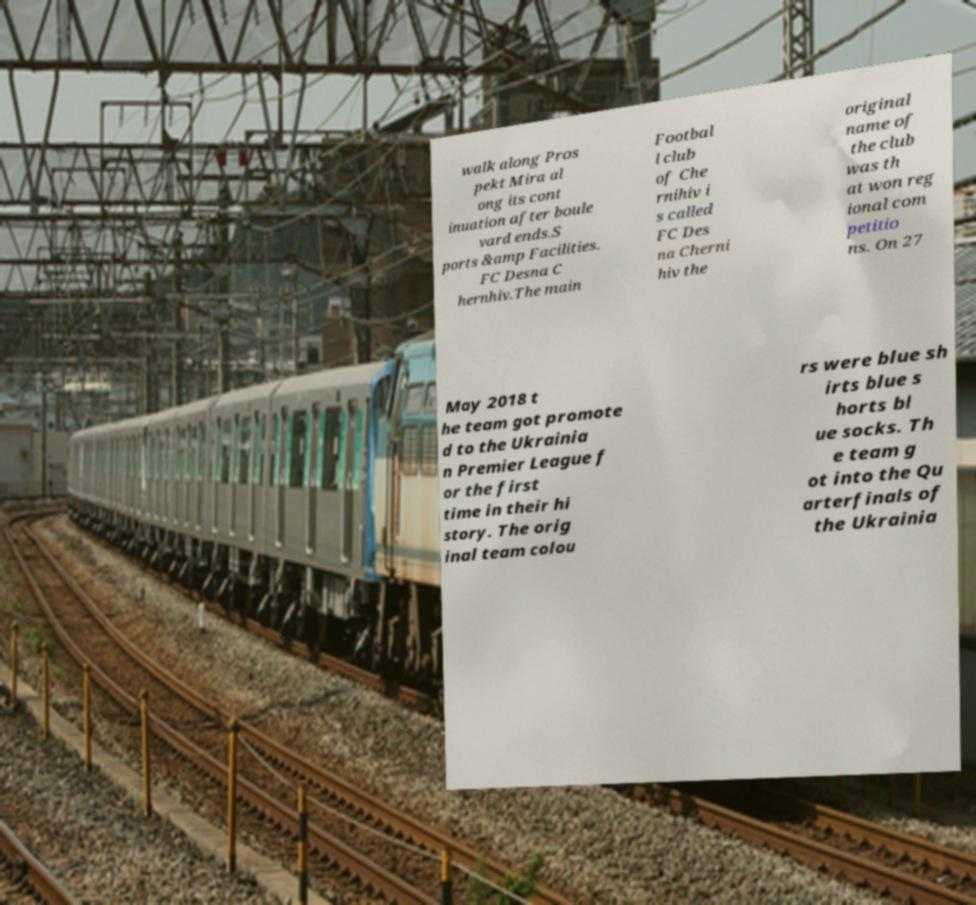For documentation purposes, I need the text within this image transcribed. Could you provide that? walk along Pros pekt Mira al ong its cont inuation after boule vard ends.S ports &amp Facilities. FC Desna C hernhiv.The main Footbal l club of Che rnihiv i s called FC Des na Cherni hiv the original name of the club was th at won reg ional com petitio ns. On 27 May 2018 t he team got promote d to the Ukrainia n Premier League f or the first time in their hi story. The orig inal team colou rs were blue sh irts blue s horts bl ue socks. Th e team g ot into the Qu arterfinals of the Ukrainia 